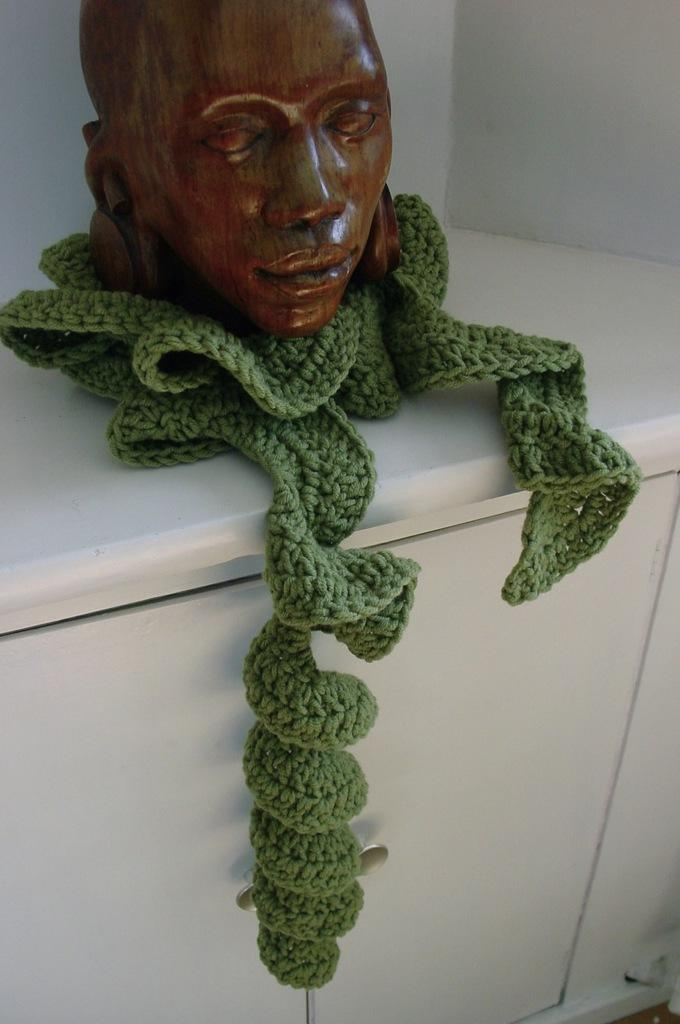What is the main subject of the image? There is a statue of a person in the image. How is the statue positioned in the image? The statue is placed on a cloth. What is the cloth placed on? The cloth is placed on a cupboard. What type of chin can be seen on the linen in the image? There is no chin or linen present in the image; it features a statue of a person placed on a cloth. What type of test is being conducted on the statue in the image? There is no test being conducted on the statue in the image; it is simply a statue placed on a cloth. 